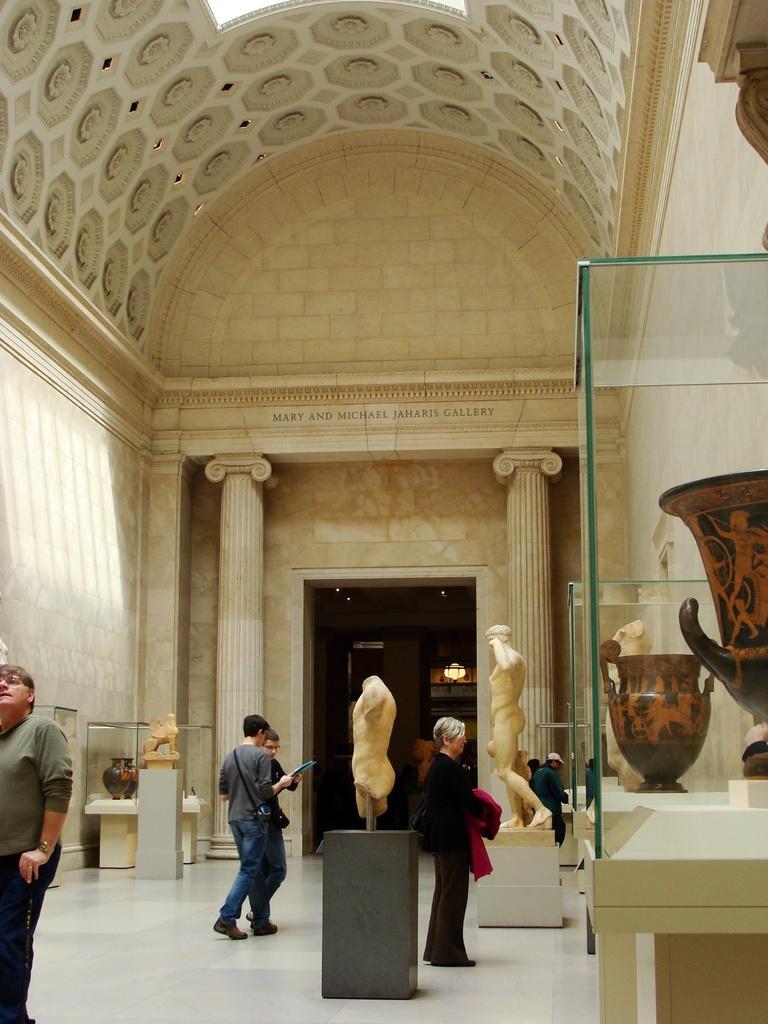Could you give a brief overview of what you see in this image? In this image there are people standing and checking out some artifacts in the museum. In the hall there are pillars and walls. At the top of the image there is a dome. In the background of the image there is an open door with chandelier in it. On top of the image there are lights. At the bottom of the image there is a floor. 